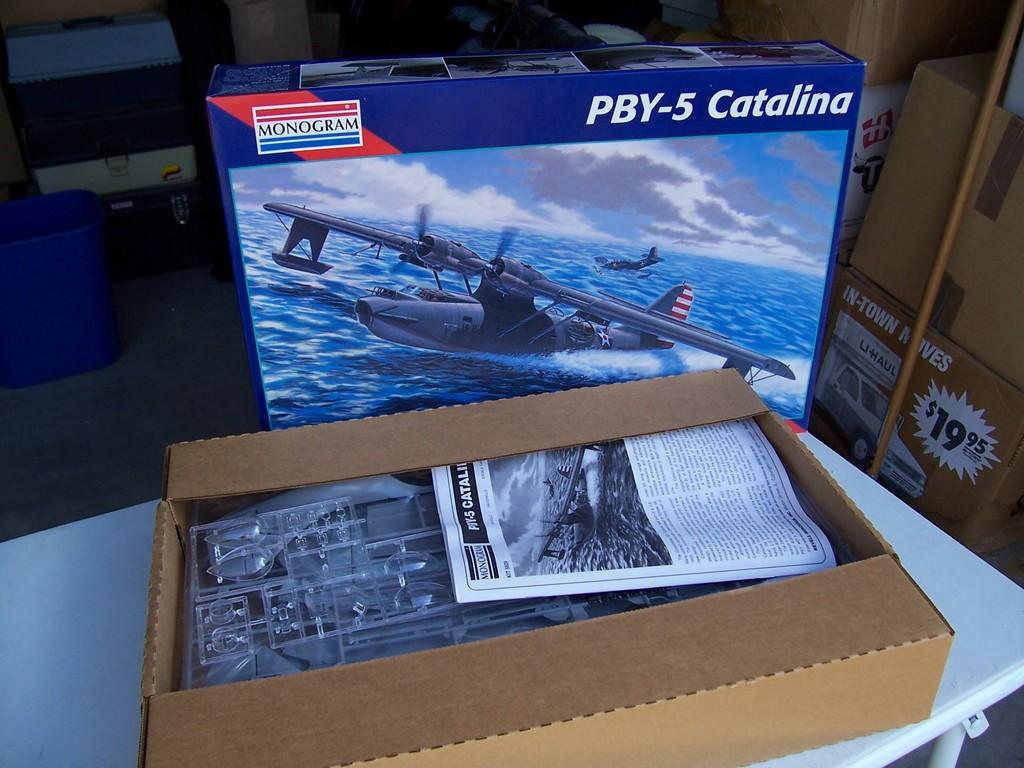<image>
Present a compact description of the photo's key features. an item with PBY-5 Catalina written on it 